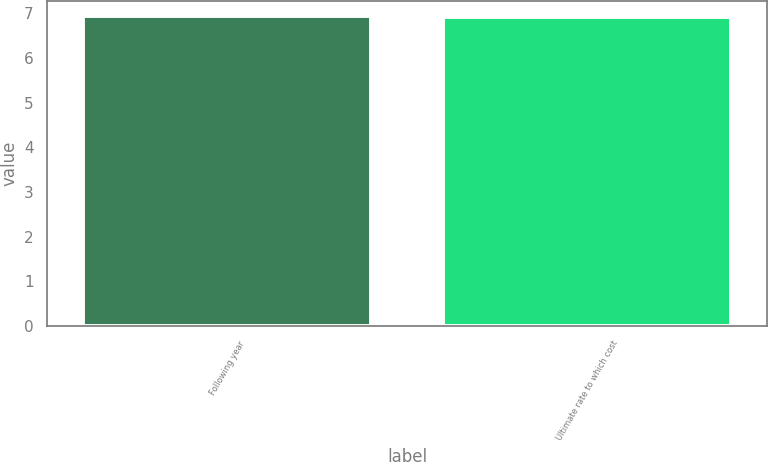<chart> <loc_0><loc_0><loc_500><loc_500><bar_chart><fcel>Following year<fcel>Ultimate rate to which cost<nl><fcel>6.94<fcel>6.93<nl></chart> 